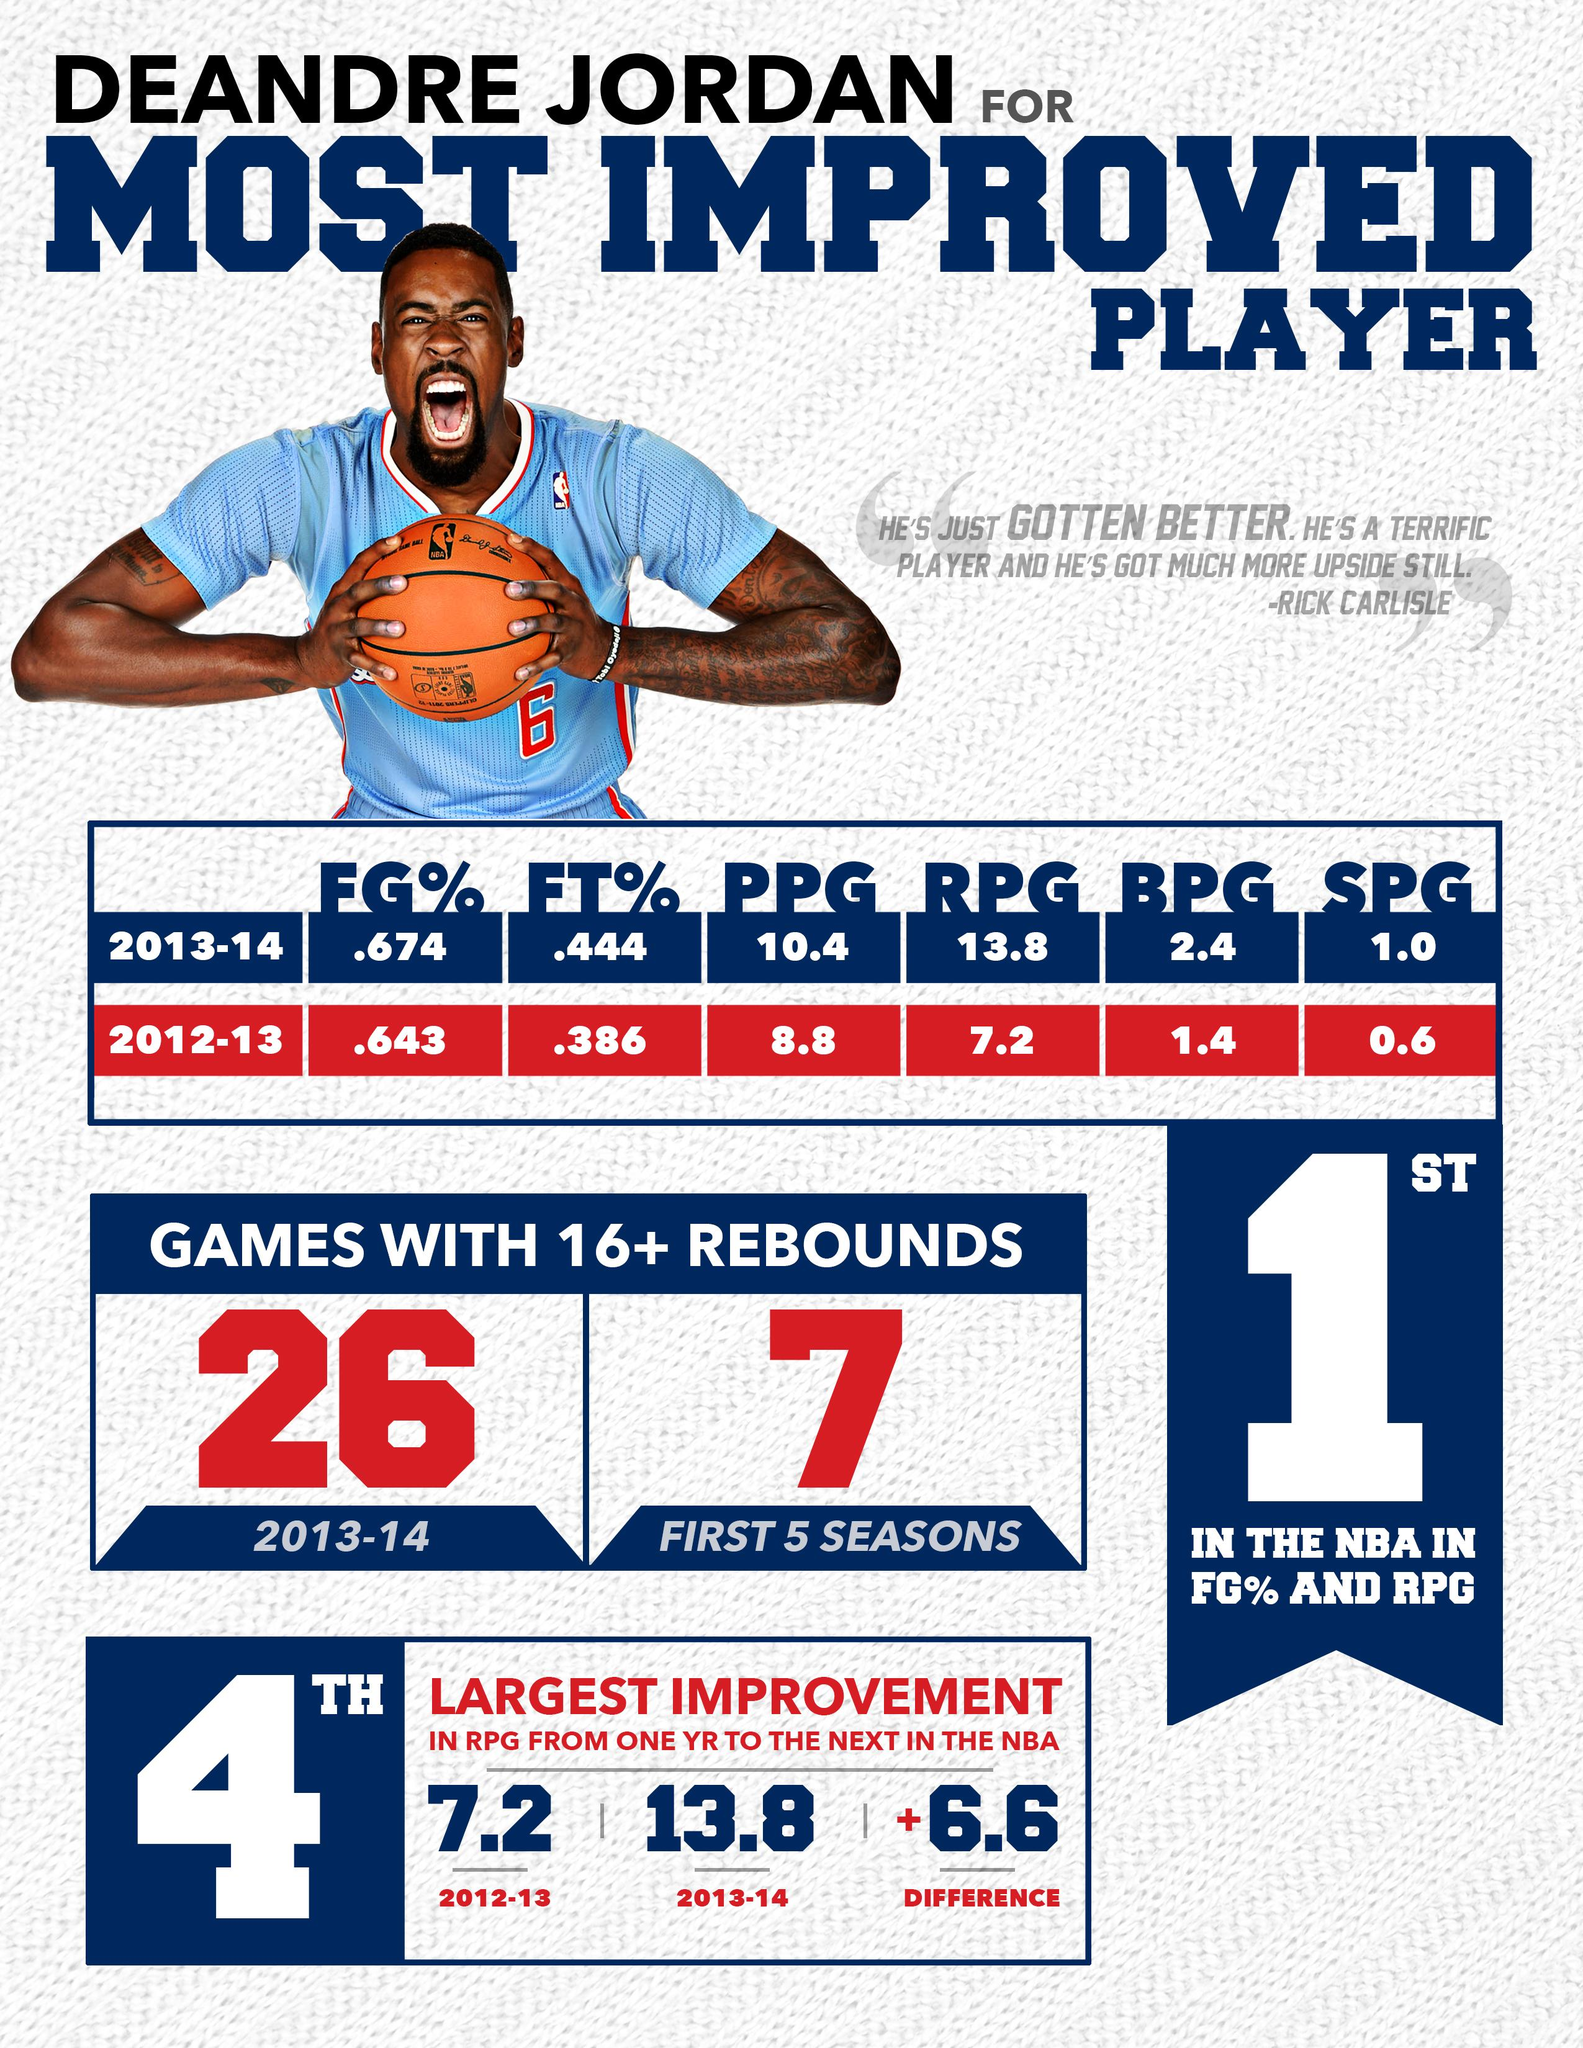Outline some significant characteristics in this image. In the 2012-2013 season, the combined percentage of free throws and field goals taken together was 1.029. In the 2013-2014 season, the percentage of field goals and free throws taken together was 1.118. 